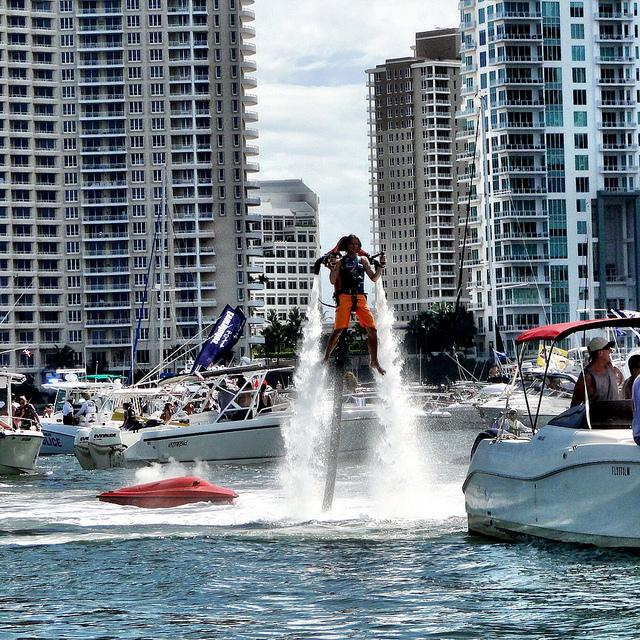What power allows the man to to airborne?

Choices:
A) water pump
B) mental
C) solar
D) magic water pump 